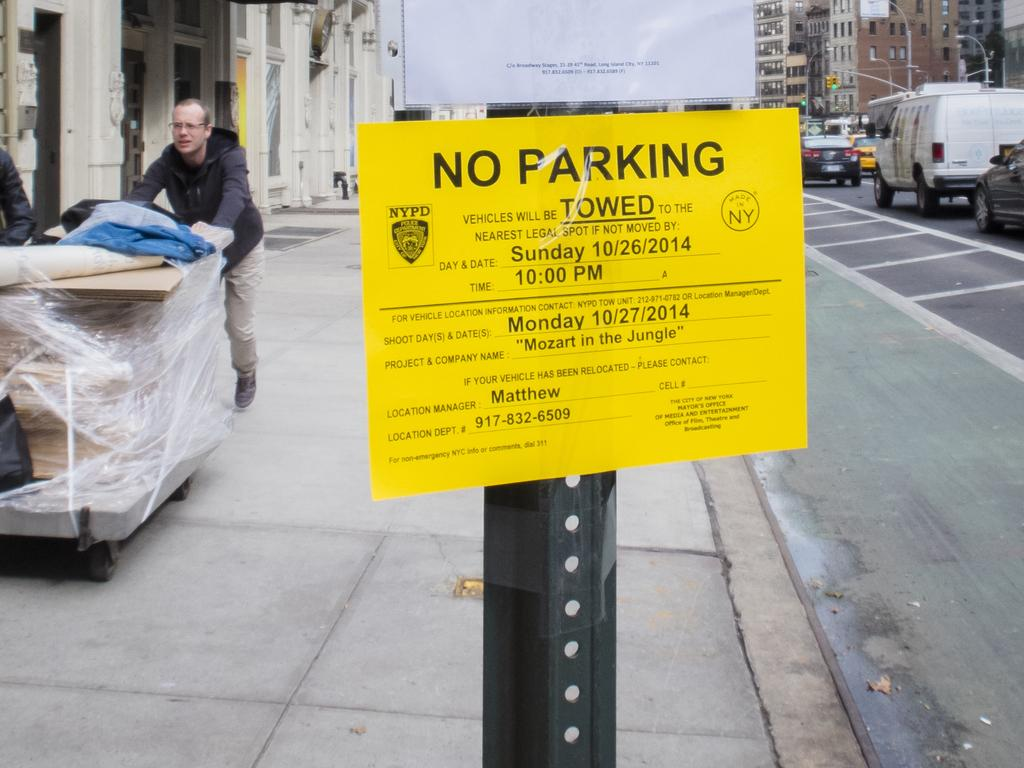Who or what is present in the image? There is a person in the image. What can be seen beneath the person's feet? The ground is visible in the image. What is located on the left side of the image? There is an object on the left side of the image. What type of structures can be seen in the image? There are buildings in the image. What are the poles used for in the image? The poles are likely used for supporting wires or other infrastructure in the image. What type of transportation is visible in the image? There are vehicles in the image. What can be read or deciphered in the image? There are boards with text in the image. How many babies are crawling on the vehicles in the image? There are no babies present in the image, and they are not crawling on the vehicles. 